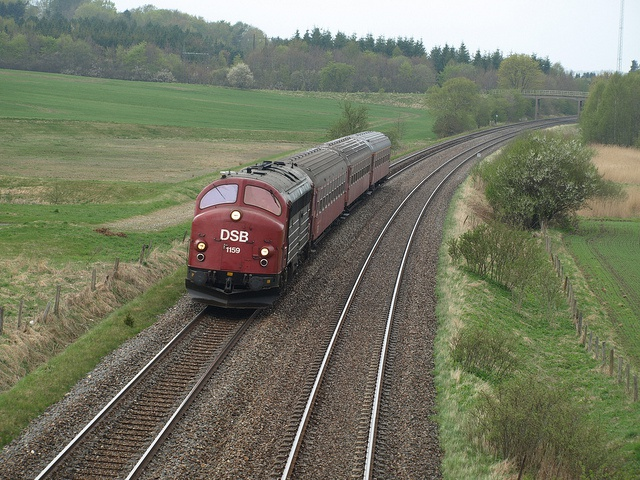Describe the objects in this image and their specific colors. I can see a train in gray, black, darkgray, and maroon tones in this image. 